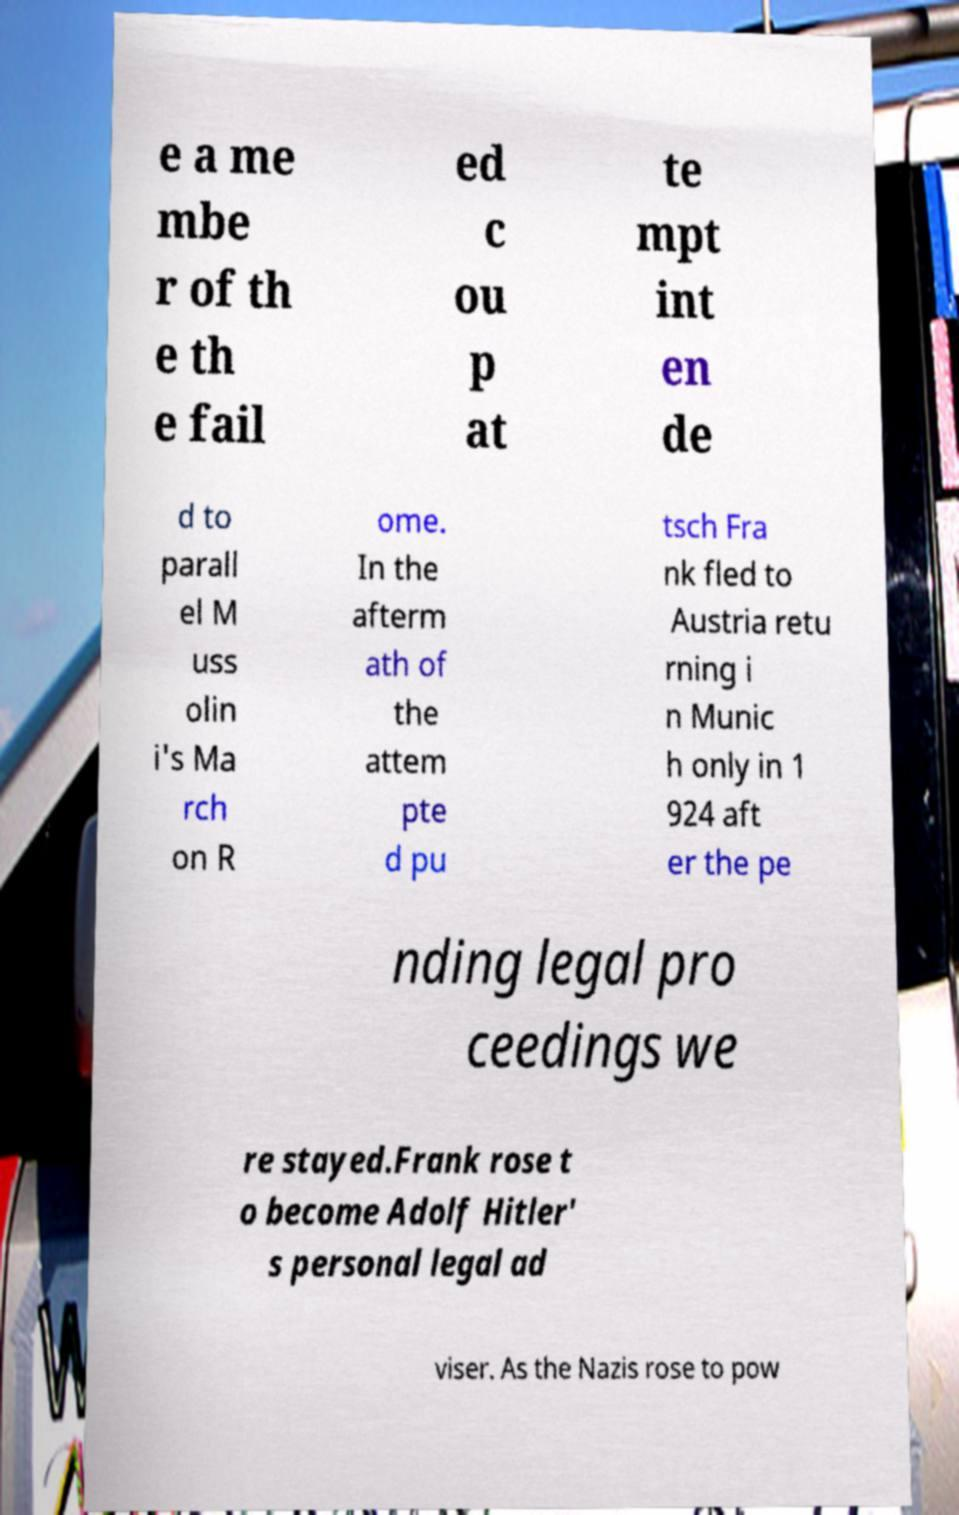For documentation purposes, I need the text within this image transcribed. Could you provide that? e a me mbe r of th e th e fail ed c ou p at te mpt int en de d to parall el M uss olin i's Ma rch on R ome. In the afterm ath of the attem pte d pu tsch Fra nk fled to Austria retu rning i n Munic h only in 1 924 aft er the pe nding legal pro ceedings we re stayed.Frank rose t o become Adolf Hitler' s personal legal ad viser. As the Nazis rose to pow 